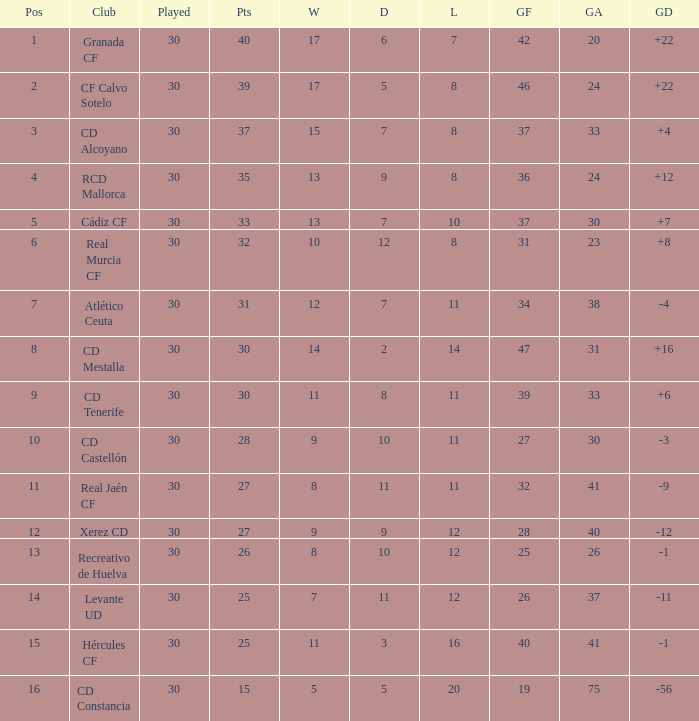Which Wins have a Goal Difference larger than 12, and a Club of granada cf, and Played larger than 30? None. 